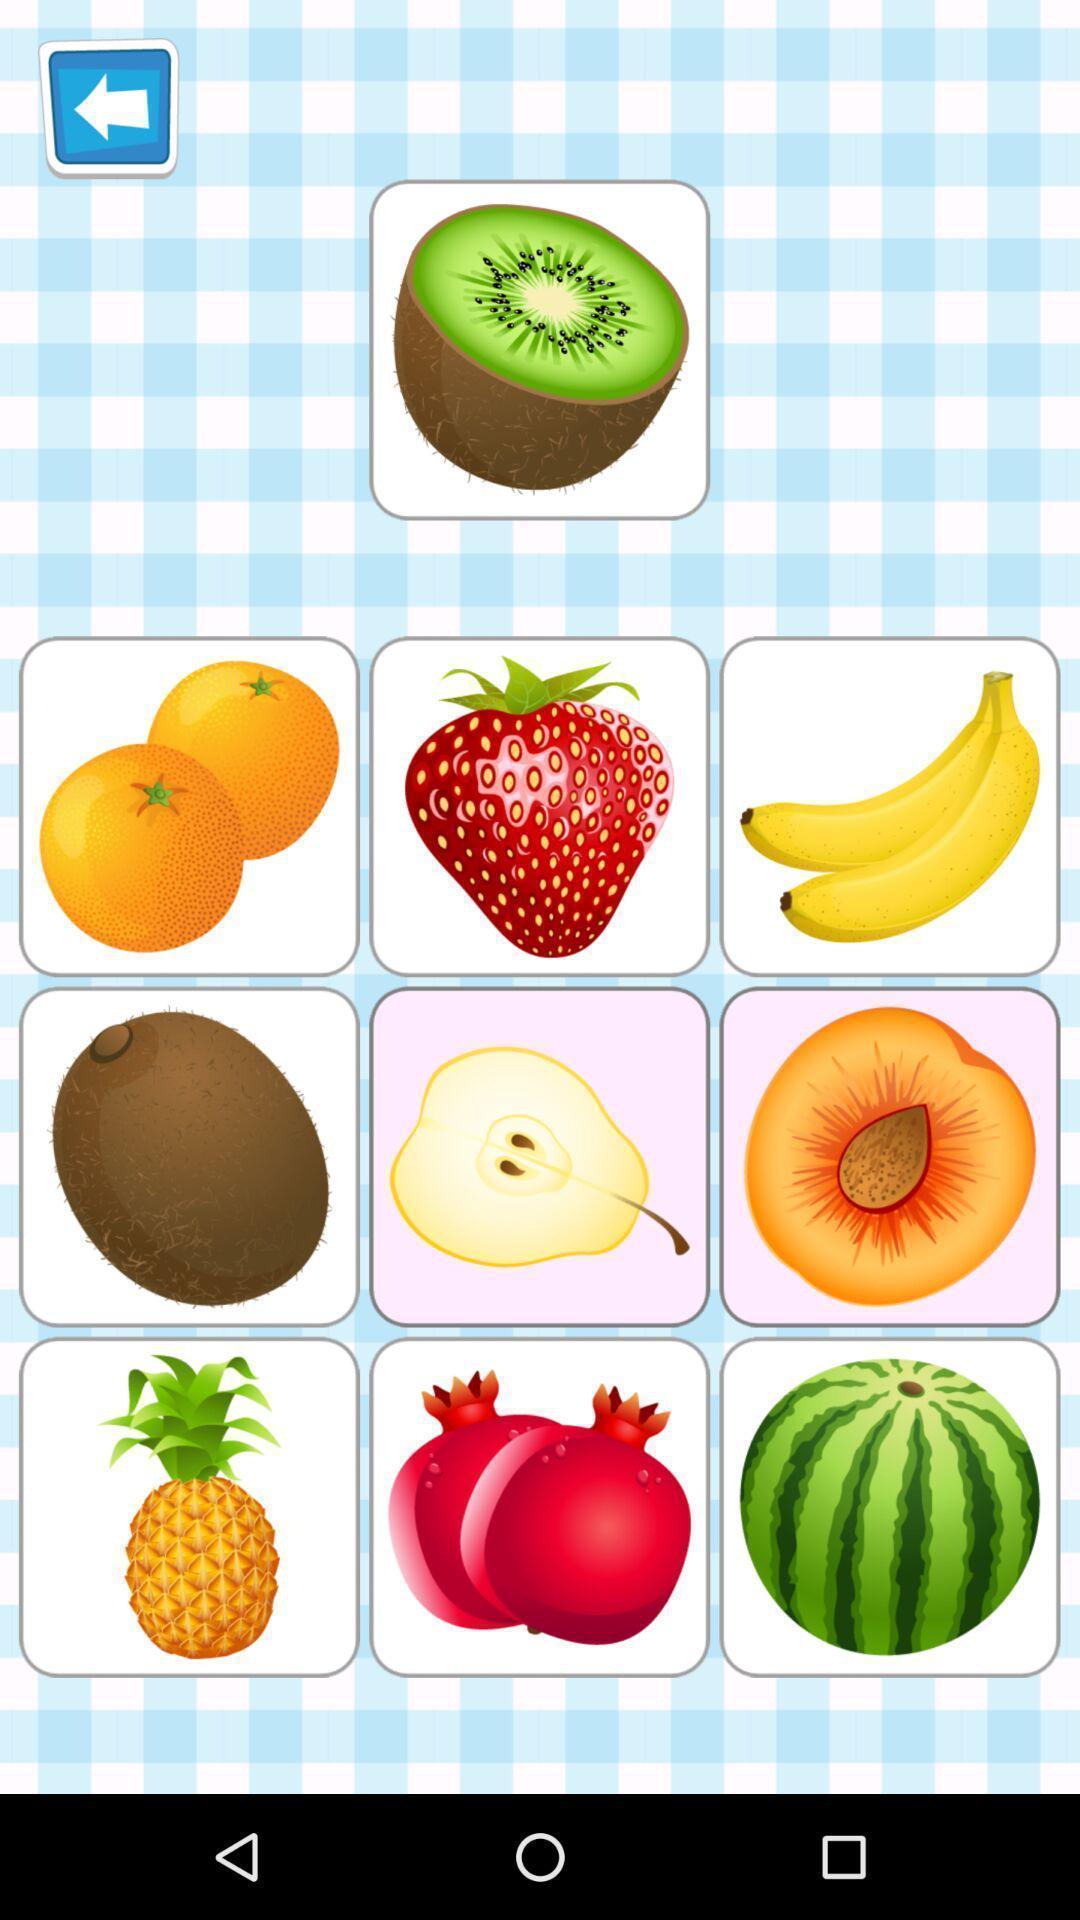Describe the key features of this screenshot. Screen displaying list of fruit icons. 